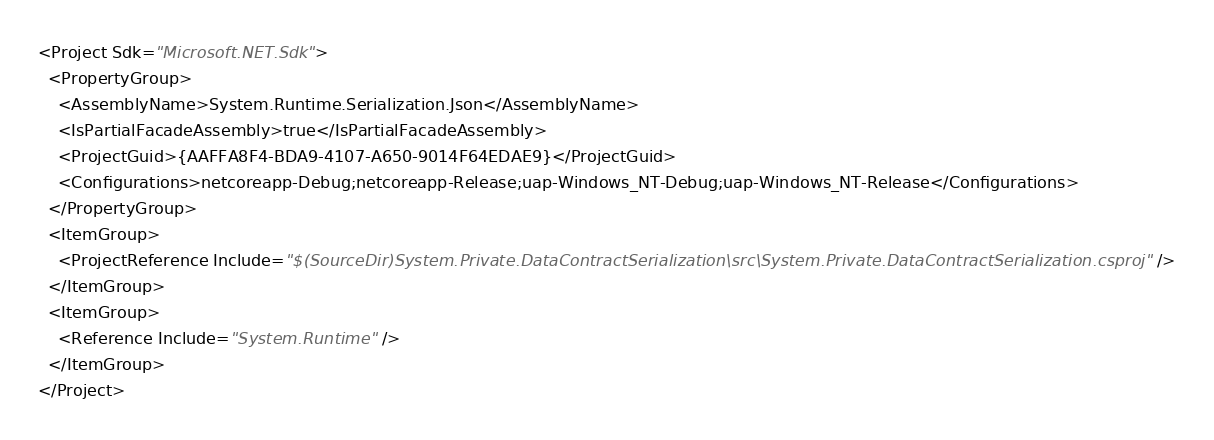<code> <loc_0><loc_0><loc_500><loc_500><_XML_><Project Sdk="Microsoft.NET.Sdk">
  <PropertyGroup>
    <AssemblyName>System.Runtime.Serialization.Json</AssemblyName>
    <IsPartialFacadeAssembly>true</IsPartialFacadeAssembly>
    <ProjectGuid>{AAFFA8F4-BDA9-4107-A650-9014F64EDAE9}</ProjectGuid>
    <Configurations>netcoreapp-Debug;netcoreapp-Release;uap-Windows_NT-Debug;uap-Windows_NT-Release</Configurations>
  </PropertyGroup>
  <ItemGroup>
    <ProjectReference Include="$(SourceDir)System.Private.DataContractSerialization\src\System.Private.DataContractSerialization.csproj" />
  </ItemGroup>
  <ItemGroup>
    <Reference Include="System.Runtime" />
  </ItemGroup>
</Project></code> 